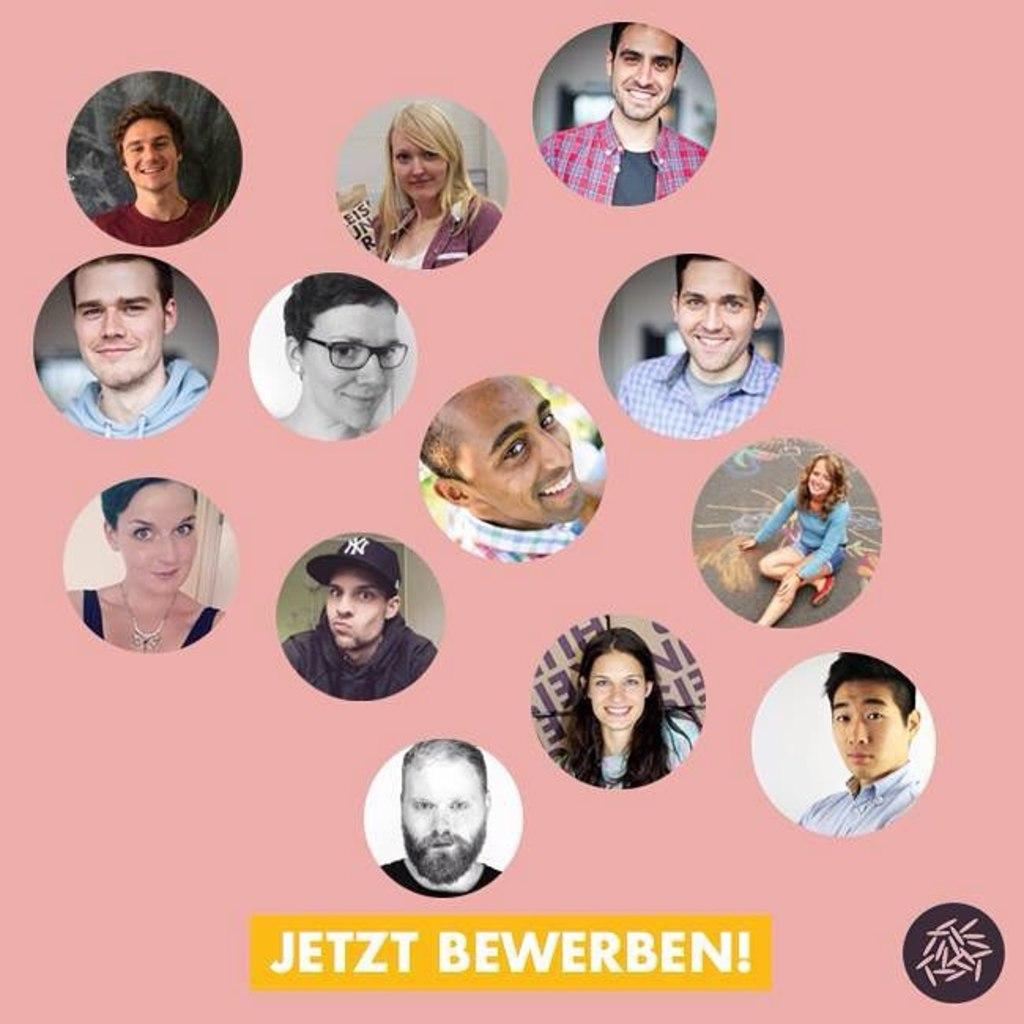What can be seen in the image besides text? There are pictures of people in the image. What is written at the bottom of the image? The text is written at the bottom of the image. What type of copper material is present in the image? There is no copper material present in the image; it features pictures of people and text. Can you describe the air quality in the image? The image is a still image, so it does not depict air quality. 